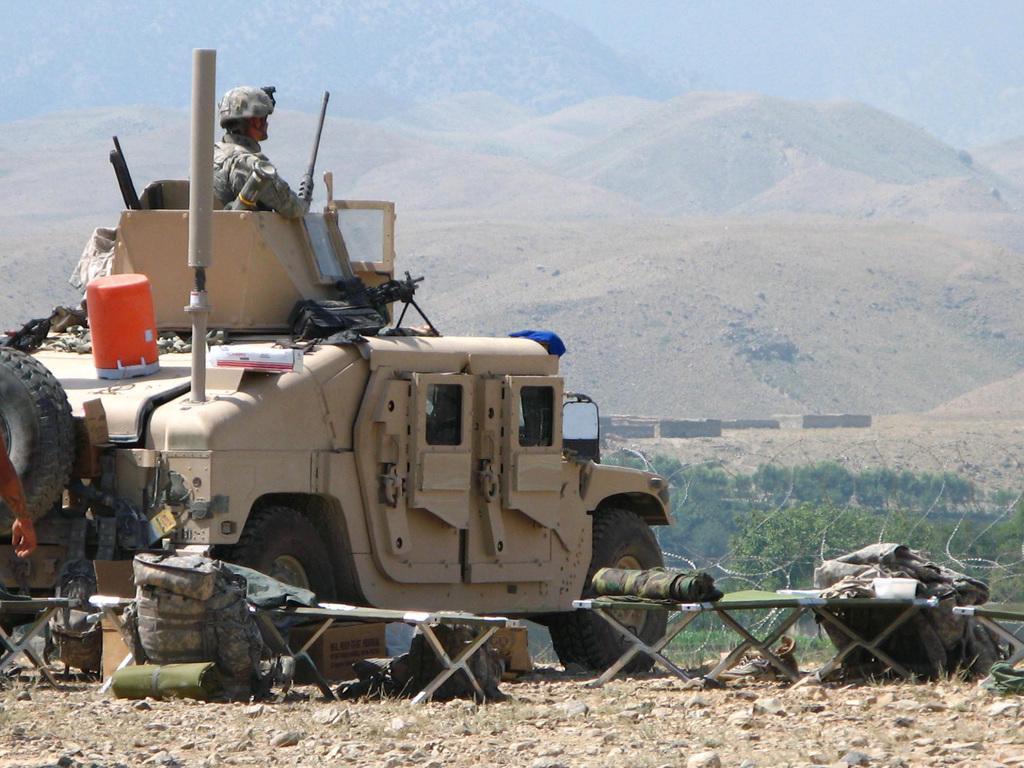Can you describe this image briefly? This is an outside view. On the left side there is a vehicle and there is one person on this vehicle. At the bottom there are few bags placed on the tables. There are many stones on the ground. In the background there are few hills. 